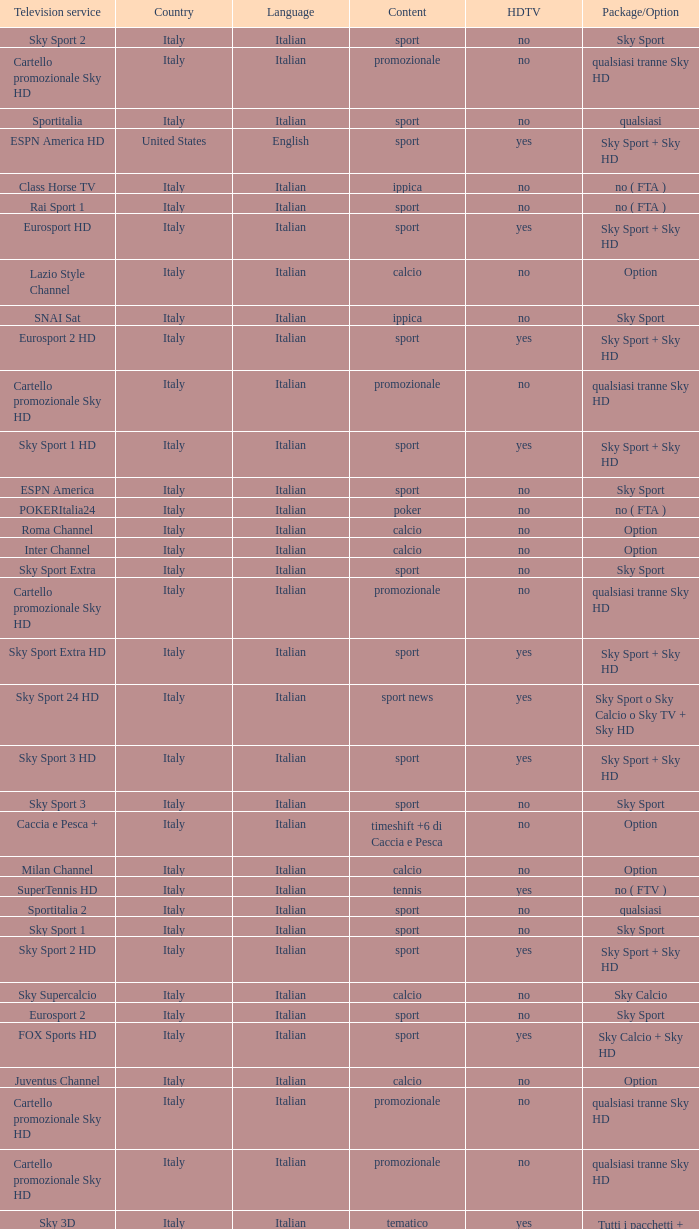What is Country, when Television Service is Eurosport 2? Italy. Give me the full table as a dictionary. {'header': ['Television service', 'Country', 'Language', 'Content', 'HDTV', 'Package/Option'], 'rows': [['Sky Sport 2', 'Italy', 'Italian', 'sport', 'no', 'Sky Sport'], ['Cartello promozionale Sky HD', 'Italy', 'Italian', 'promozionale', 'no', 'qualsiasi tranne Sky HD'], ['Sportitalia', 'Italy', 'Italian', 'sport', 'no', 'qualsiasi'], ['ESPN America HD', 'United States', 'English', 'sport', 'yes', 'Sky Sport + Sky HD'], ['Class Horse TV', 'Italy', 'Italian', 'ippica', 'no', 'no ( FTA )'], ['Rai Sport 1', 'Italy', 'Italian', 'sport', 'no', 'no ( FTA )'], ['Eurosport HD', 'Italy', 'Italian', 'sport', 'yes', 'Sky Sport + Sky HD'], ['Lazio Style Channel', 'Italy', 'Italian', 'calcio', 'no', 'Option'], ['SNAI Sat', 'Italy', 'Italian', 'ippica', 'no', 'Sky Sport'], ['Eurosport 2 HD', 'Italy', 'Italian', 'sport', 'yes', 'Sky Sport + Sky HD'], ['Cartello promozionale Sky HD', 'Italy', 'Italian', 'promozionale', 'no', 'qualsiasi tranne Sky HD'], ['Sky Sport 1 HD', 'Italy', 'Italian', 'sport', 'yes', 'Sky Sport + Sky HD'], ['ESPN America', 'Italy', 'Italian', 'sport', 'no', 'Sky Sport'], ['POKERItalia24', 'Italy', 'Italian', 'poker', 'no', 'no ( FTA )'], ['Roma Channel', 'Italy', 'Italian', 'calcio', 'no', 'Option'], ['Inter Channel', 'Italy', 'Italian', 'calcio', 'no', 'Option'], ['Sky Sport Extra', 'Italy', 'Italian', 'sport', 'no', 'Sky Sport'], ['Cartello promozionale Sky HD', 'Italy', 'Italian', 'promozionale', 'no', 'qualsiasi tranne Sky HD'], ['Sky Sport Extra HD', 'Italy', 'Italian', 'sport', 'yes', 'Sky Sport + Sky HD'], ['Sky Sport 24 HD', 'Italy', 'Italian', 'sport news', 'yes', 'Sky Sport o Sky Calcio o Sky TV + Sky HD'], ['Sky Sport 3 HD', 'Italy', 'Italian', 'sport', 'yes', 'Sky Sport + Sky HD'], ['Sky Sport 3', 'Italy', 'Italian', 'sport', 'no', 'Sky Sport'], ['Caccia e Pesca +', 'Italy', 'Italian', 'timeshift +6 di Caccia e Pesca', 'no', 'Option'], ['Milan Channel', 'Italy', 'Italian', 'calcio', 'no', 'Option'], ['SuperTennis HD', 'Italy', 'Italian', 'tennis', 'yes', 'no ( FTV )'], ['Sportitalia 2', 'Italy', 'Italian', 'sport', 'no', 'qualsiasi'], ['Sky Sport 1', 'Italy', 'Italian', 'sport', 'no', 'Sky Sport'], ['Sky Sport 2 HD', 'Italy', 'Italian', 'sport', 'yes', 'Sky Sport + Sky HD'], ['Sky Supercalcio', 'Italy', 'Italian', 'calcio', 'no', 'Sky Calcio'], ['Eurosport 2', 'Italy', 'Italian', 'sport', 'no', 'Sky Sport'], ['FOX Sports HD', 'Italy', 'Italian', 'sport', 'yes', 'Sky Calcio + Sky HD'], ['Juventus Channel', 'Italy', 'Italian', 'calcio', 'no', 'Option'], ['Cartello promozionale Sky HD', 'Italy', 'Italian', 'promozionale', 'no', 'qualsiasi tranne Sky HD'], ['Cartello promozionale Sky HD', 'Italy', 'Italian', 'promozionale', 'no', 'qualsiasi tranne Sky HD'], ['Sky 3D', 'Italy', 'Italian', 'tematico', 'yes', 'Tutti i pacchetti + Sky HD'], ['Eurosport', 'Italy', 'Italian', 'sport', 'no', 'Sky Sport'], ['ESPN Classic', 'Italy', 'Italian', 'sport', 'no', 'Sky Sport'], ['Cartello promozionale Sky HD', 'Italy', 'Italian', 'promozionale', 'no', 'qualsiasi tranne Sky HD'], ['Rai Sport 2', 'Italy', 'Italian', 'sport', 'no', 'no ( FTA )'], ['Caccia e Pesca', 'Italy', 'Italian', 'caccia e pesca', 'no', 'Option']]} 